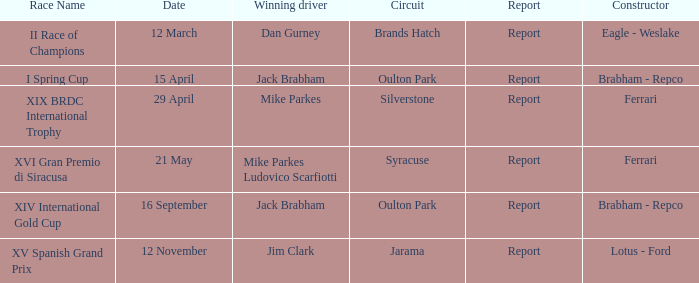What is the name of the race on 16 september? XIV International Gold Cup. 